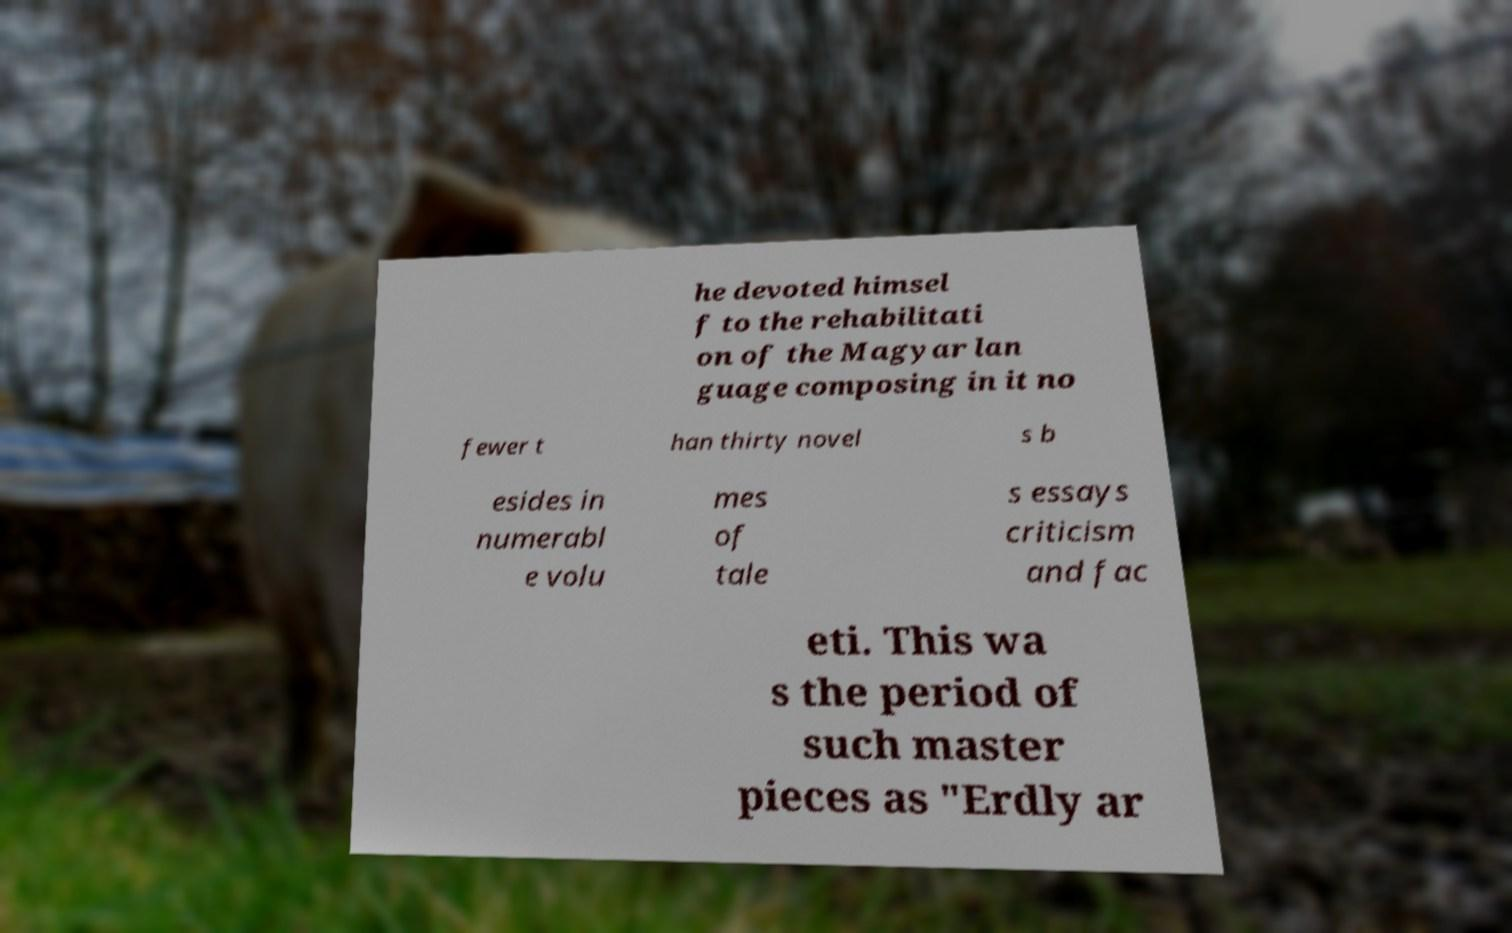I need the written content from this picture converted into text. Can you do that? he devoted himsel f to the rehabilitati on of the Magyar lan guage composing in it no fewer t han thirty novel s b esides in numerabl e volu mes of tale s essays criticism and fac eti. This wa s the period of such master pieces as "Erdly ar 